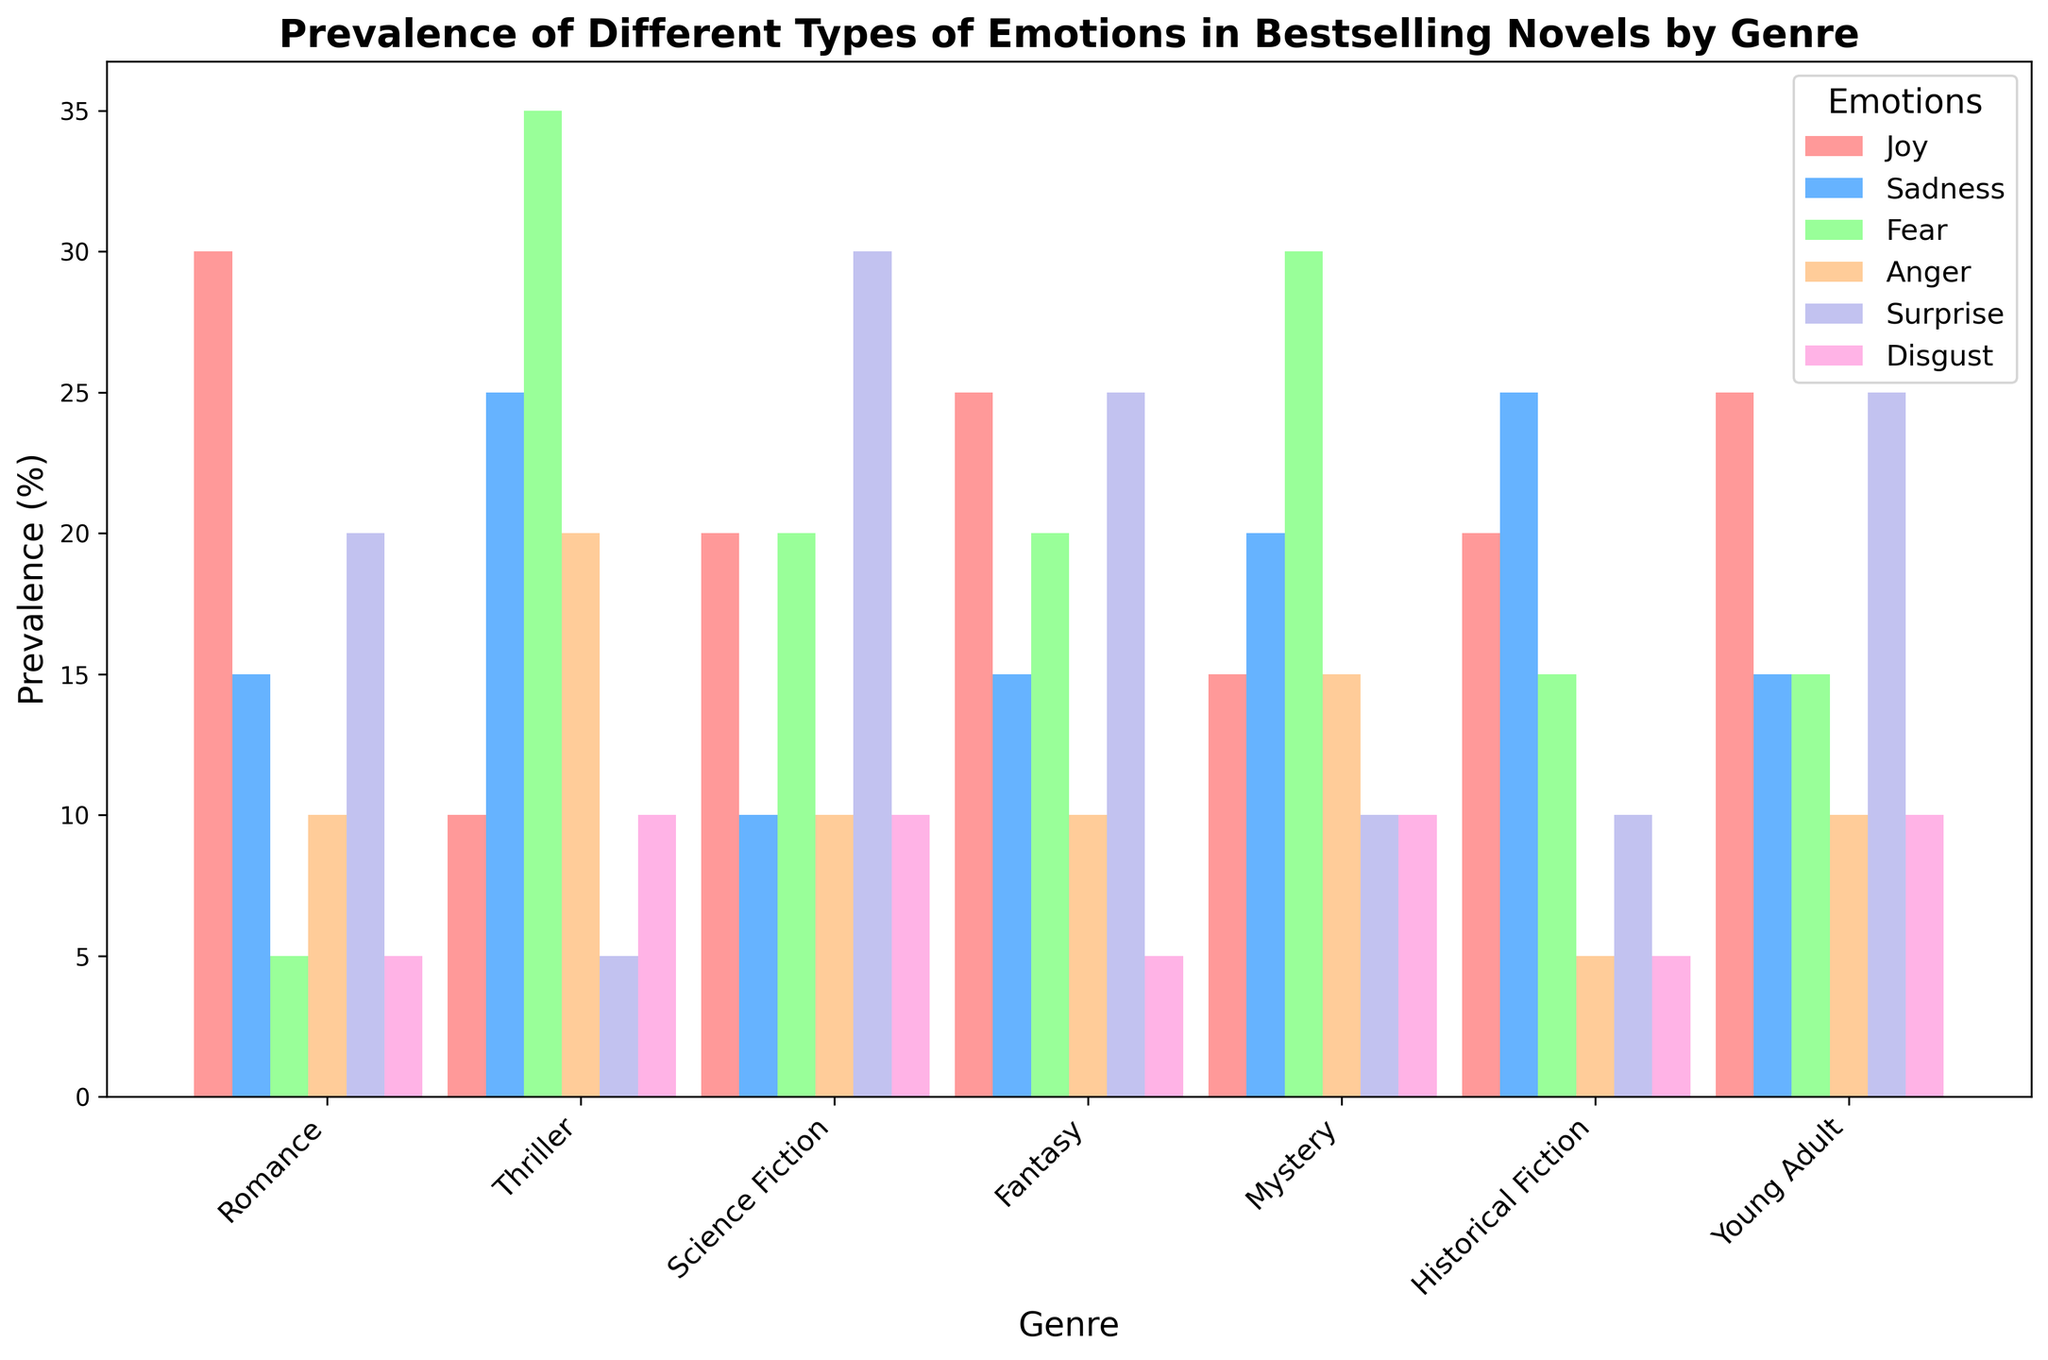How prevalent is Joy in Romance compared to Science Fiction? To compare the prevalence of Joy in Romance and Science Fiction, check the Joy bars for both genres. Romance has a Joy value of 30, while Science Fiction has a Joy value of 20. Romance has a higher prevalence of Joy by 10.
Answer: Romance is higher by 10 Which genre has the highest prevalence of Fear, and what is the value? To determine the genre with the highest prevalence of Fear, locate the tallest bar in the Fear section. Thriller has the highest prevalence of Fear with a value of 35.
Answer: Thriller with 35 What is the total prevalence of Sadness across all genres? Sum the Sadness values from all genres: Romance (15) + Thriller (25) + Science Fiction (10) + Fantasy (15) + Mystery (20) + Historical Fiction (25) + Young Adult (15). The total is 125.
Answer: 125 Which genre exhibits more Surprise: Fantasy or Mystery? Compare the height of the Surprise bars for Fantasy and Mystery. Fantasy has a value of 25, and Mystery has a value of 10. Fantasy exhibits more Surprise by 15.
Answer: Fantasy is higher by 15 What is the average prevalence of Anger across all genres? To find the average, sum the Anger values from all genres (10 from Romance, 20 from Thriller, 10 from Science Fiction, 10 from Fantasy, 15 from Mystery, 5 from Historical Fiction, and 10 from Young Adult) and divide by the number of genres, which is 7. The total is 80, and the average is 80/7 ≈ 11.43.
Answer: Approximately 11.43 How does the prevalence of Joy in Fantasy compare to that in Young Adult? Check the Joy bars for Fantasy and Young Adult. Both have a value of 25, so the prevalence of Joy in Fantasy is equal to Young Adult.
Answer: Equal Which emotion is most prevalent in Historical Fiction, and what is the value? Identify the tallest bar for Historical Fiction. Sadness has the highest value at 25.
Answer: Sadness with 25 What is the combined prevalence of Disgust in Thriller and Mystery? Add the Disgust values for Thriller (10) and Mystery (10). The combined total is 10 + 10 = 20.
Answer: 20 Which emotion has the least prevalence in Romance? Identify the shortest bar for Romance. Both Fear and Disgust have the lowest value of 5.
Answer: Fear and Disgust Of all the emotions, which one is least represented in Science Fiction, and what is the value? Determine the shortest bar in Science Fiction. Sadness has the lowest value at 10.
Answer: Sadness with 10 